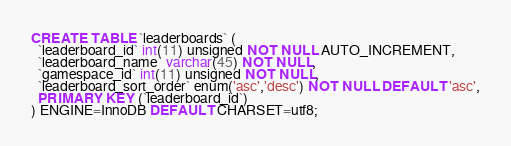Convert code to text. <code><loc_0><loc_0><loc_500><loc_500><_SQL_>CREATE TABLE `leaderboards` (
  `leaderboard_id` int(11) unsigned NOT NULL AUTO_INCREMENT,
  `leaderboard_name` varchar(45) NOT NULL,
  `gamespace_id` int(11) unsigned NOT NULL,
  `leaderboard_sort_order` enum('asc','desc') NOT NULL DEFAULT 'asc',
  PRIMARY KEY (`leaderboard_id`)
) ENGINE=InnoDB DEFAULT CHARSET=utf8;</code> 